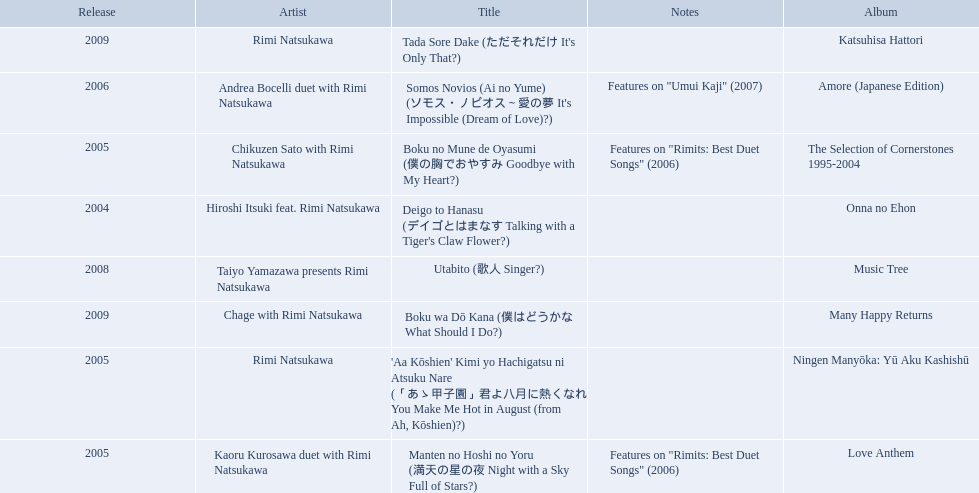Which title of the rimi natsukawa discography was released in the 2004? Deigo to Hanasu (デイゴとはまなす Talking with a Tiger's Claw Flower?). Which title has notes that features on/rimits. best duet songs\2006 Manten no Hoshi no Yoru (満天の星の夜 Night with a Sky Full of Stars?). Which title share the same notes as night with a sky full of stars? Boku no Mune de Oyasumi (僕の胸でおやすみ Goodbye with My Heart?). What are the notes for sky full of stars? Features on "Rimits: Best Duet Songs" (2006). What other song features this same note? Boku no Mune de Oyasumi (僕の胸でおやすみ Goodbye with My Heart?). When was onna no ehon released? 2004. When was the selection of cornerstones 1995-2004 released? 2005. What was released in 2008? Music Tree. Would you be able to parse every entry in this table? {'header': ['Release', 'Artist', 'Title', 'Notes', 'Album'], 'rows': [['2009', 'Rimi Natsukawa', "Tada Sore Dake (ただそれだけ It's Only That?)", '', 'Katsuhisa Hattori'], ['2006', 'Andrea Bocelli duet with Rimi Natsukawa', "Somos Novios (Ai no Yume) (ソモス・ノビオス～愛の夢 It's Impossible (Dream of Love)?)", 'Features on "Umui Kaji" (2007)', 'Amore (Japanese Edition)'], ['2005', 'Chikuzen Sato with Rimi Natsukawa', 'Boku no Mune de Oyasumi (僕の胸でおやすみ Goodbye with My Heart?)', 'Features on "Rimits: Best Duet Songs" (2006)', 'The Selection of Cornerstones 1995-2004'], ['2004', 'Hiroshi Itsuki feat. Rimi Natsukawa', "Deigo to Hanasu (デイゴとはまなす Talking with a Tiger's Claw Flower?)", '', 'Onna no Ehon'], ['2008', 'Taiyo Yamazawa presents Rimi Natsukawa', 'Utabito (歌人 Singer?)', '', 'Music Tree'], ['2009', 'Chage with Rimi Natsukawa', 'Boku wa Dō Kana (僕はどうかな What Should I Do?)', '', 'Many Happy Returns'], ['2005', 'Rimi Natsukawa', "'Aa Kōshien' Kimi yo Hachigatsu ni Atsuku Nare (「あゝ甲子園」君よ八月に熱くなれ You Make Me Hot in August (from Ah, Kōshien)?)", '', 'Ningen Manyōka: Yū Aku Kashishū'], ['2005', 'Kaoru Kurosawa duet with Rimi Natsukawa', 'Manten no Hoshi no Yoru (満天の星の夜 Night with a Sky Full of Stars?)', 'Features on "Rimits: Best Duet Songs" (2006)', 'Love Anthem']]} 